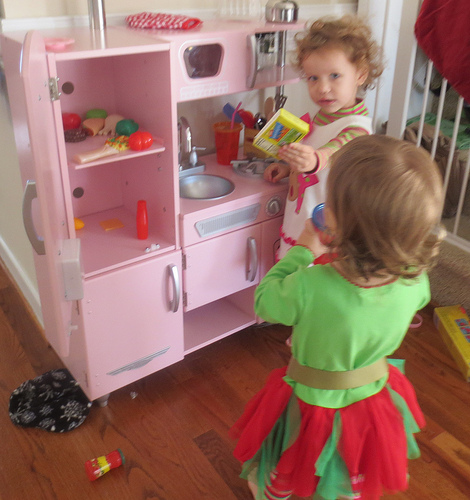<image>
Can you confirm if the box is on the baby? No. The box is not positioned on the baby. They may be near each other, but the box is not supported by or resting on top of the baby. 